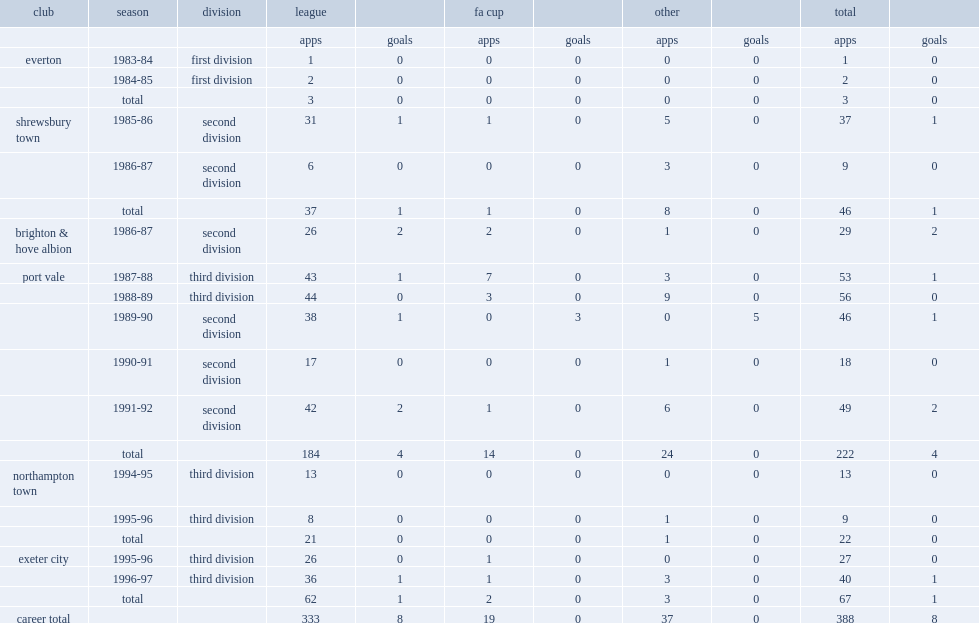How many cup appearances did darren hughes make for six clubs? 388.0. 